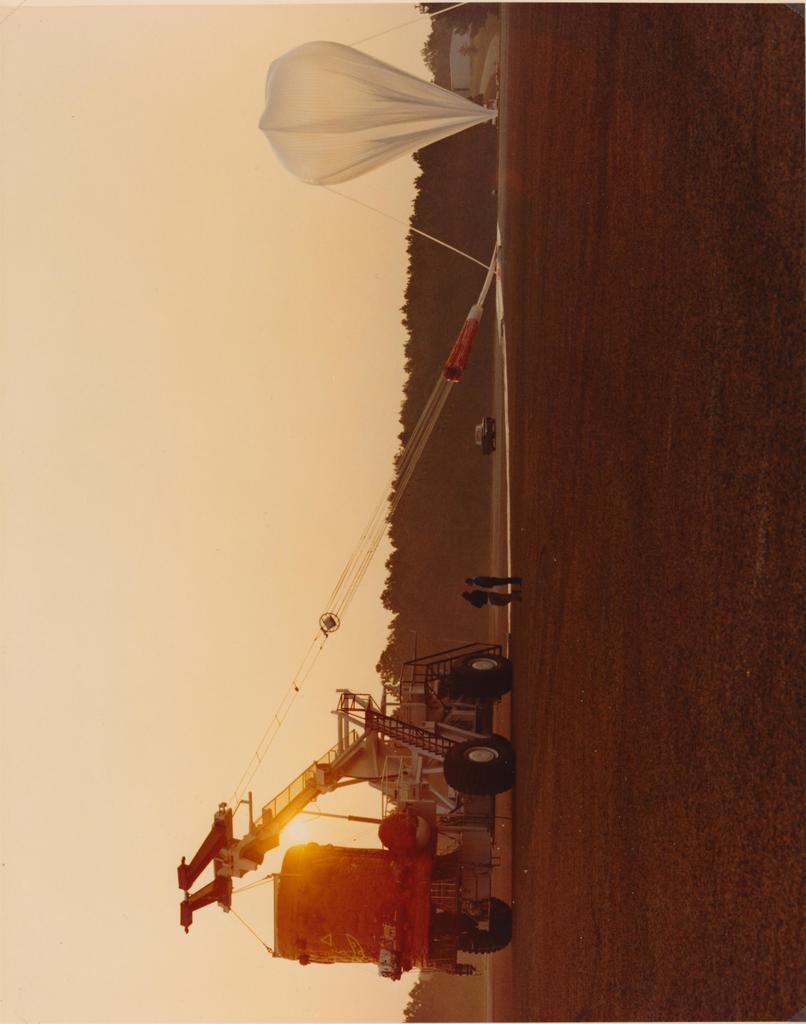How would you summarize this image in a sentence or two? In this image we can see a vast land. One And one parachute and vehicle is there. Background of the image trees are present. Left side of the image sky is there. 